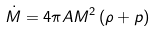Convert formula to latex. <formula><loc_0><loc_0><loc_500><loc_500>\dot { M } = 4 \pi A M ^ { 2 } \left ( \rho + p \right )</formula> 